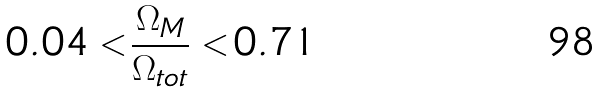Convert formula to latex. <formula><loc_0><loc_0><loc_500><loc_500>0 . 0 4 < \frac { \Omega _ { M } } { \Omega _ { t o t } } < 0 . 7 1</formula> 